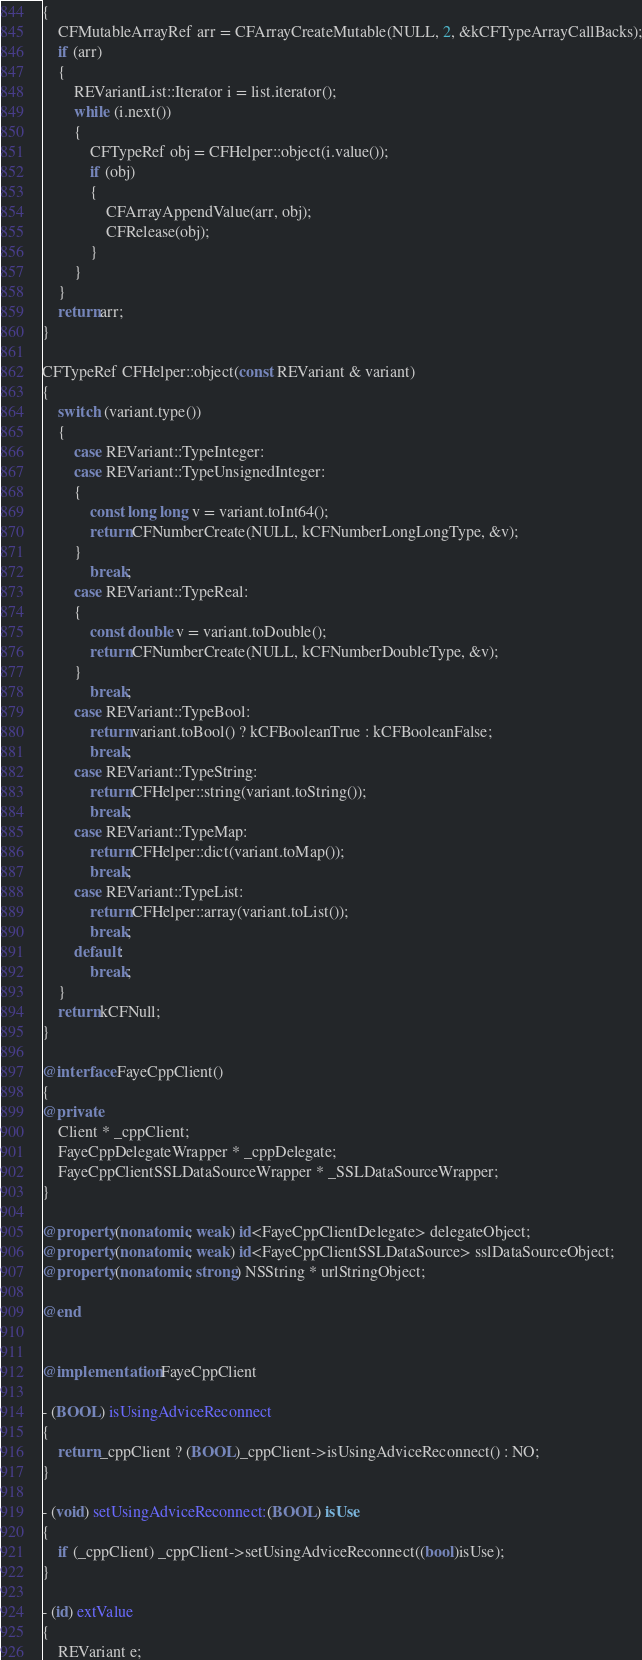<code> <loc_0><loc_0><loc_500><loc_500><_ObjectiveC_>{
	CFMutableArrayRef arr = CFArrayCreateMutable(NULL, 2, &kCFTypeArrayCallBacks);
	if (arr)
	{
		REVariantList::Iterator i = list.iterator();
		while (i.next())
		{
			CFTypeRef obj = CFHelper::object(i.value());
			if (obj)
			{
				CFArrayAppendValue(arr, obj);
				CFRelease(obj);
			}
		}
	}
	return arr;
}

CFTypeRef CFHelper::object(const REVariant & variant)
{
	switch (variant.type())
	{
		case REVariant::TypeInteger:
		case REVariant::TypeUnsignedInteger:
		{
			const long long v = variant.toInt64();
			return CFNumberCreate(NULL, kCFNumberLongLongType, &v);
		}
			break;
		case REVariant::TypeReal:
		{
			const double v = variant.toDouble();
			return CFNumberCreate(NULL, kCFNumberDoubleType, &v);
		}
			break;
		case REVariant::TypeBool:
			return variant.toBool() ? kCFBooleanTrue : kCFBooleanFalse;
			break;
		case REVariant::TypeString:
			return CFHelper::string(variant.toString());
			break;
		case REVariant::TypeMap:
			return CFHelper::dict(variant.toMap());
			break;
		case REVariant::TypeList:
			return CFHelper::array(variant.toList());
			break;
		default:
			break;
	}
	return kCFNull;
}

@interface FayeCppClient()
{
@private
	Client * _cppClient;
	FayeCppDelegateWrapper * _cppDelegate;
	FayeCppClientSSLDataSourceWrapper * _SSLDataSourceWrapper;
}

@property (nonatomic, weak) id<FayeCppClientDelegate> delegateObject;
@property (nonatomic, weak) id<FayeCppClientSSLDataSource> sslDataSourceObject;
@property (nonatomic, strong) NSString * urlStringObject;

@end


@implementation FayeCppClient

- (BOOL) isUsingAdviceReconnect
{
	return _cppClient ? (BOOL)_cppClient->isUsingAdviceReconnect() : NO;
}

- (void) setUsingAdviceReconnect:(BOOL) isUse
{
	if (_cppClient) _cppClient->setUsingAdviceReconnect((bool)isUse);
}

- (id) extValue
{
	REVariant e;</code> 